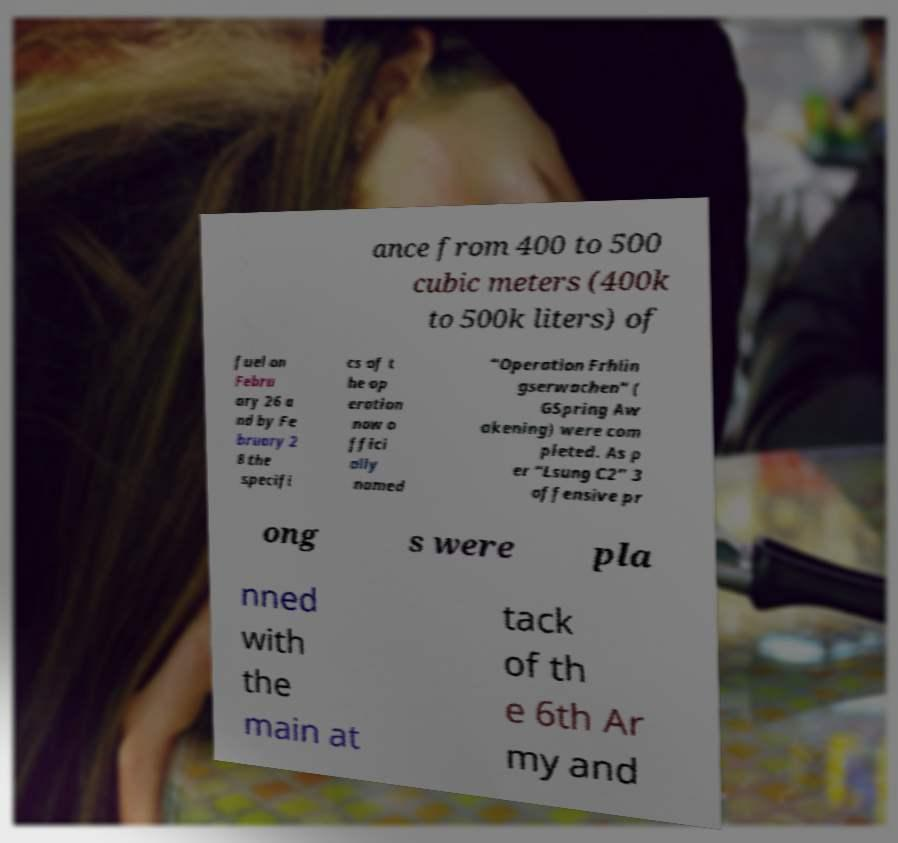Please identify and transcribe the text found in this image. ance from 400 to 500 cubic meters (400k to 500k liters) of fuel on Febru ary 26 a nd by Fe bruary 2 8 the specifi cs of t he op eration now o ffici ally named “Operation Frhlin gserwachen” ( GSpring Aw akening) were com pleted. As p er “Lsung C2” 3 offensive pr ong s were pla nned with the main at tack of th e 6th Ar my and 